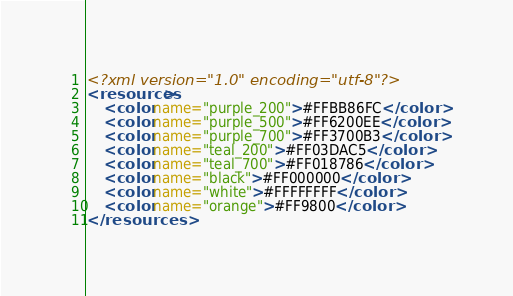<code> <loc_0><loc_0><loc_500><loc_500><_XML_><?xml version="1.0" encoding="utf-8"?>
<resources>
    <color name="purple_200">#FFBB86FC</color>
    <color name="purple_500">#FF6200EE</color>
    <color name="purple_700">#FF3700B3</color>
    <color name="teal_200">#FF03DAC5</color>
    <color name="teal_700">#FF018786</color>
    <color name="black">#FF000000</color>
    <color name="white">#FFFFFFFF</color>
    <color name="orange">#FF9800</color>
</resources></code> 